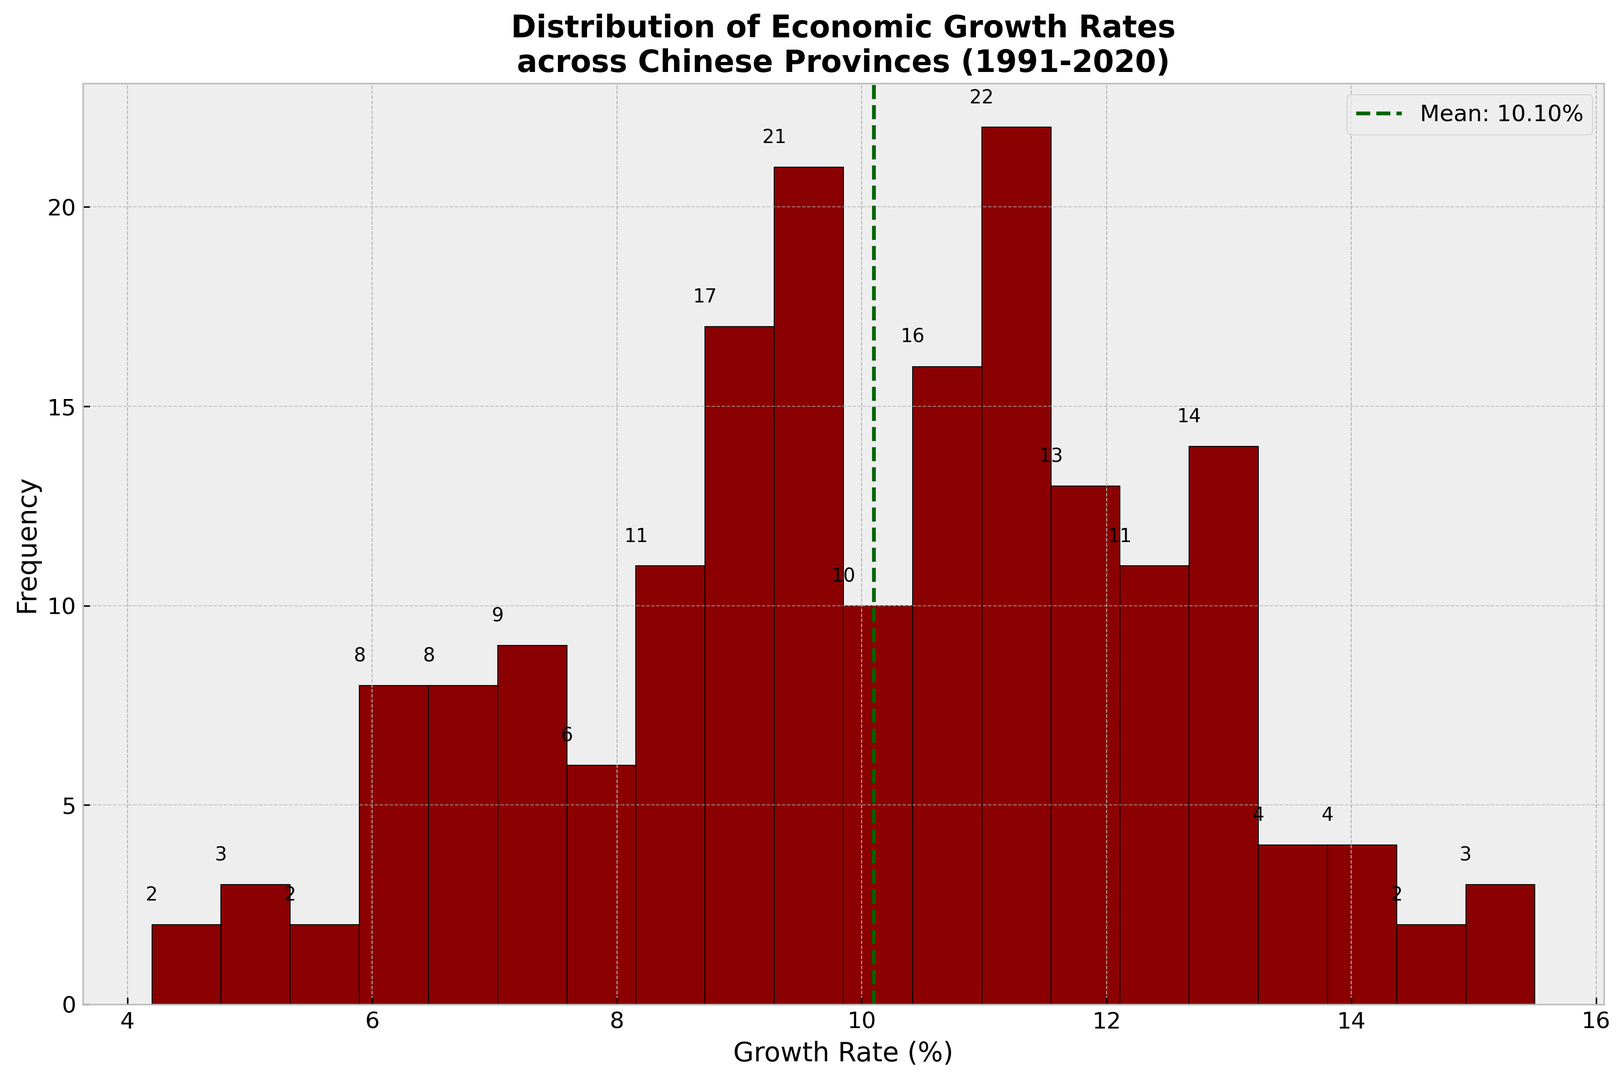what information does the highlighted dotted line represent in the histogram? The dotted line represents the mean growth rate across all the provinces for the given periods. This visual guide helps to compare individual growth rates with the overall average.
Answer: Mean Growth Rate How many growth rates fall within the range of 8% to 10%? Count the bars that fall within the specified range in the histogram and each of their frequencies.
Answer: 25 Is the economic growth distribution more skewed towards higher or lower growth rates? Observe the histogram to see if most frequencies are clustered towards the lower or higher end of the rate spectrum.
Answer: Lower Growth Rates Compare the heights of the histograms for 6-7% and 12-13% economic growth rates. Which is taller? Look at the histogram and compare the heights of the bars representing the 6-7% and 12-13% ranges.
Answer: 6-7% Range What is the most common range of economic growth rates? Identify the bar in the histogram with the highest frequency.
Answer: 10-11% Are there more provinces with growth rates above or below the mean? Compare the number of provinces (or frequencies in the histogram) on each side of the mean growth rate line.
Answer: Below Mean What is the range in the histogram with the least frequency? Look for the smallest bar in the histogram and note its range.
Answer: 14-16% Are there any outliers in the growth rate distributions? Identify bars in the histogram that are significantly separated from the others.
Answer: No Outliers What color is used to represent the bars in the histogram? Observe the color of the bars in the histogram.
Answer: Red 